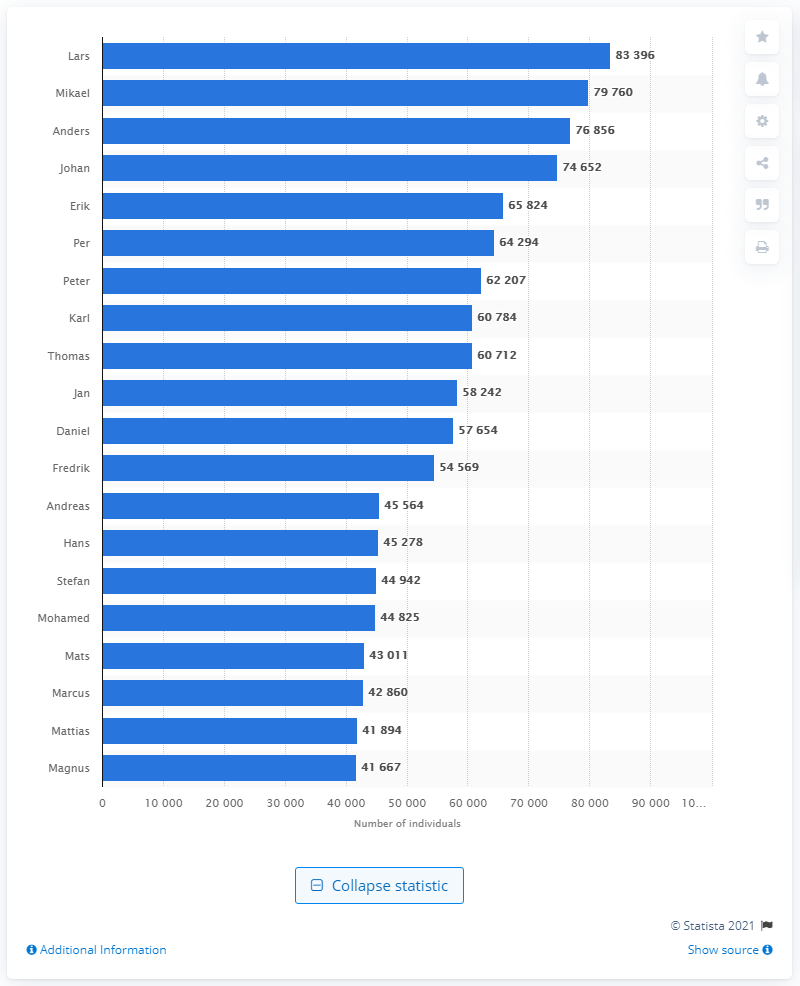Identify some key points in this picture. It is known that the most popular name in Sweden in 2020 was Lars. The name Mikael is the most popular male name in Sweden. 